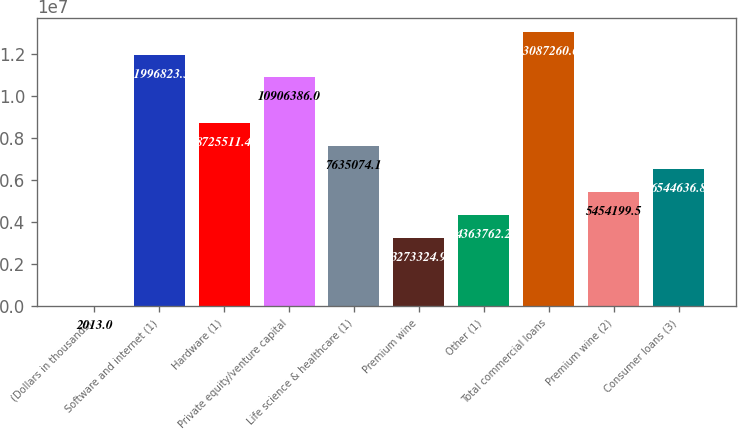Convert chart to OTSL. <chart><loc_0><loc_0><loc_500><loc_500><bar_chart><fcel>(Dollars in thousands)<fcel>Software and internet (1)<fcel>Hardware (1)<fcel>Private equity/venture capital<fcel>Life science & healthcare (1)<fcel>Premium wine<fcel>Other (1)<fcel>Total commercial loans<fcel>Premium wine (2)<fcel>Consumer loans (3)<nl><fcel>2013<fcel>1.19968e+07<fcel>8.72551e+06<fcel>1.09064e+07<fcel>7.63507e+06<fcel>3.27332e+06<fcel>4.36376e+06<fcel>1.30873e+07<fcel>5.4542e+06<fcel>6.54464e+06<nl></chart> 